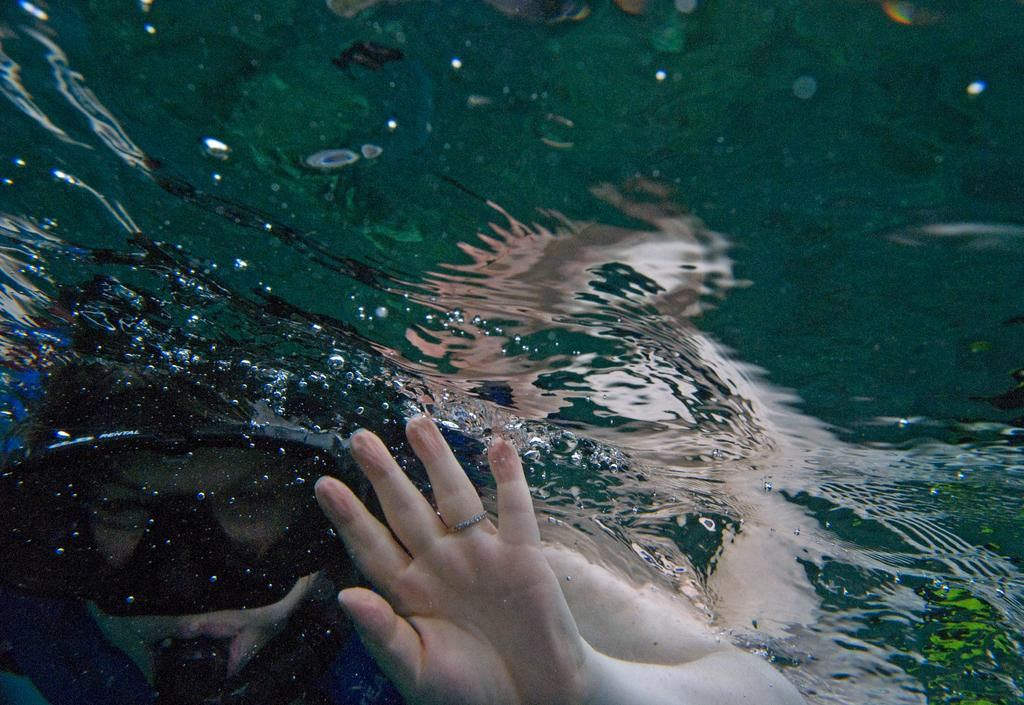What is the person in the image doing? There is a person in the water in the image. Can you describe any specific body part of the person that is visible? The hand of a person is visible in the image. What type of yarn is being used to control the speed of the person in the water? There is no yarn present in the image, and the person's speed is not being controlled by any means shown. 